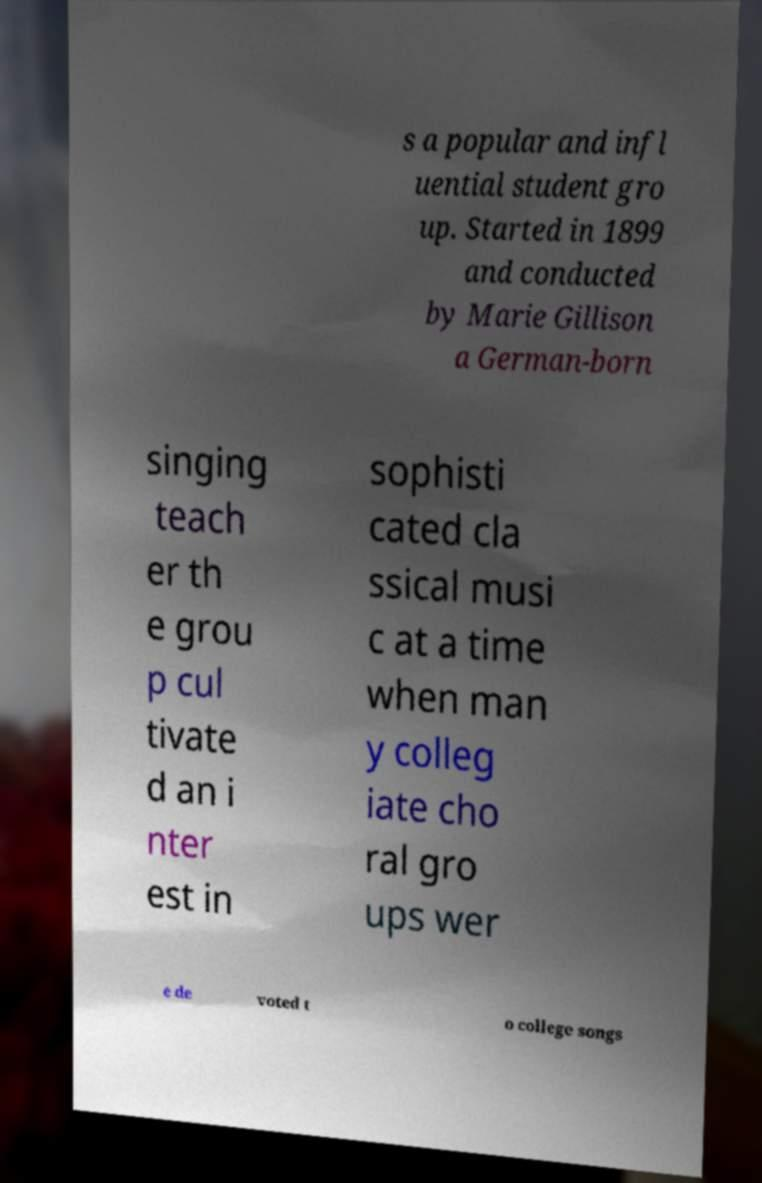Could you extract and type out the text from this image? s a popular and infl uential student gro up. Started in 1899 and conducted by Marie Gillison a German-born singing teach er th e grou p cul tivate d an i nter est in sophisti cated cla ssical musi c at a time when man y colleg iate cho ral gro ups wer e de voted t o college songs 